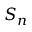<formula> <loc_0><loc_0><loc_500><loc_500>S _ { n }</formula> 